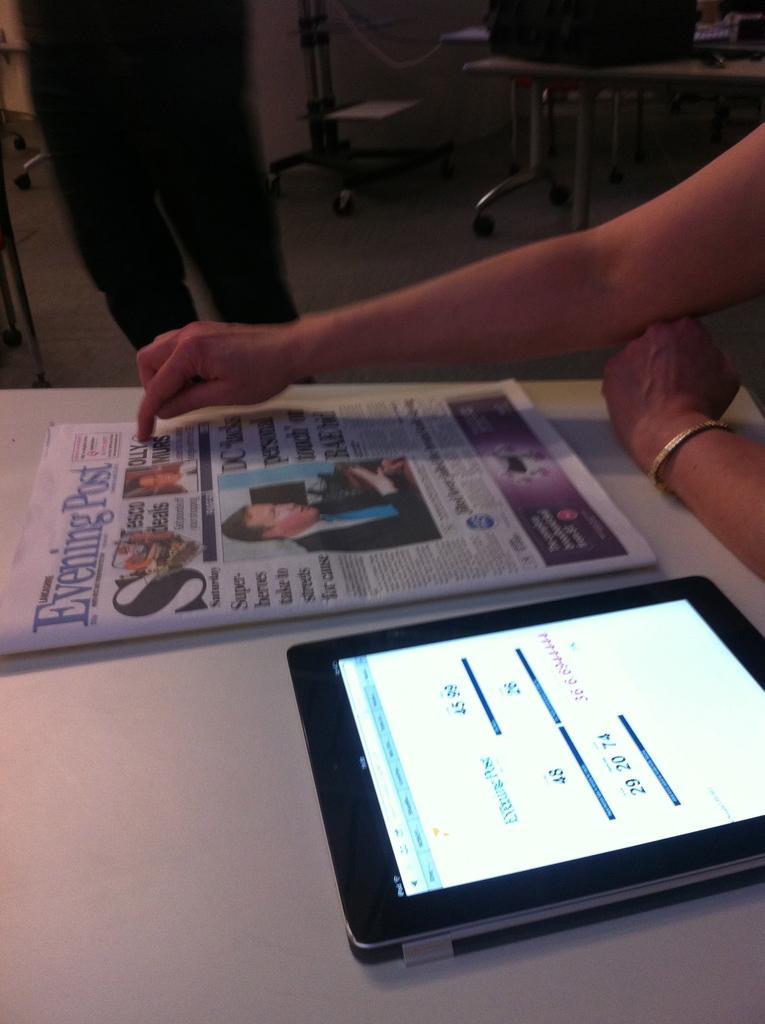Could you give a brief overview of what you see in this image? This picture contains a newspaper and a tablet are placed on a white table. We see the hand of a human pointing towards the newspaper. Beside him, we see chairs and a table and we even see the man in black pant is standing. This picture is clicked inside the room. 